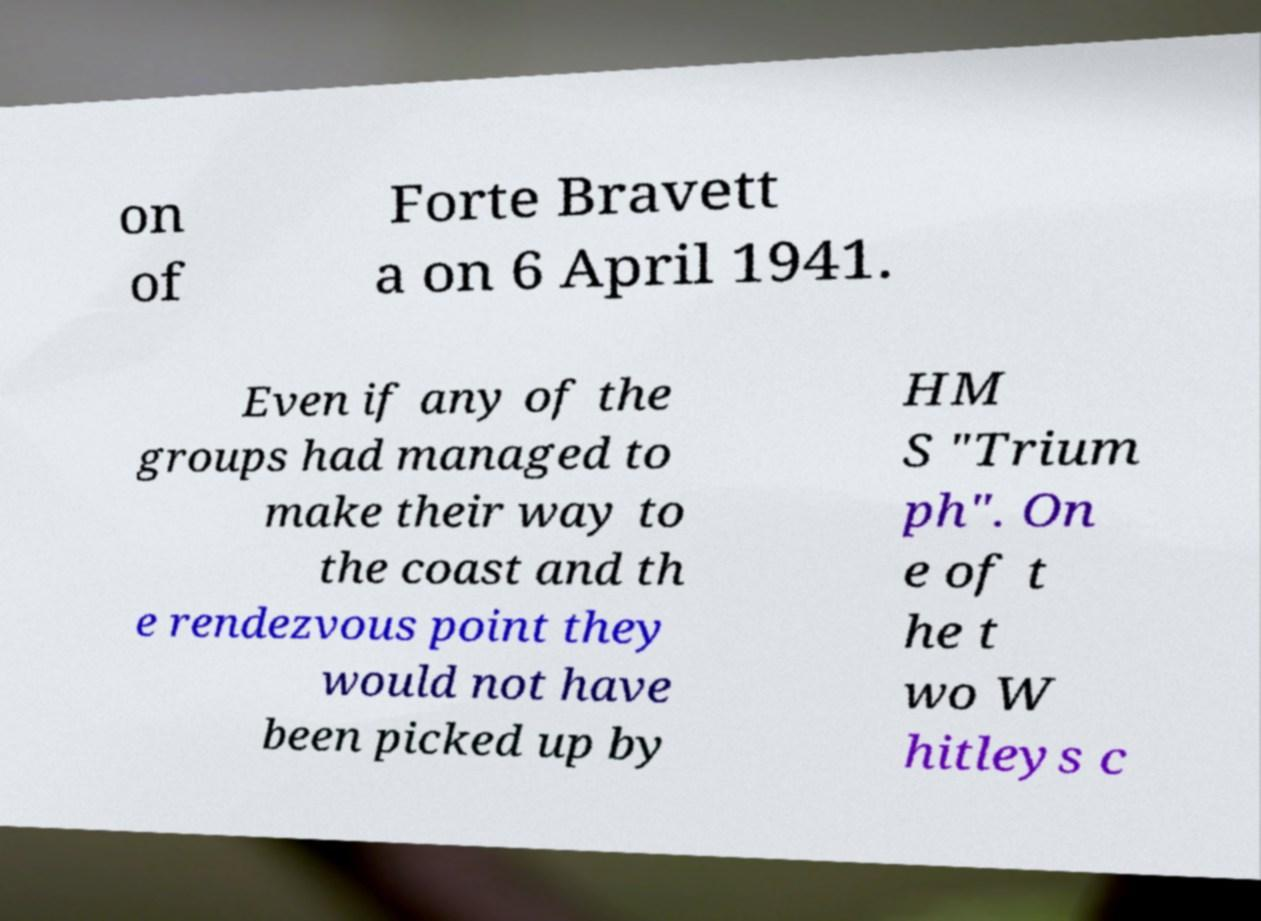Please read and relay the text visible in this image. What does it say? on of Forte Bravett a on 6 April 1941. Even if any of the groups had managed to make their way to the coast and th e rendezvous point they would not have been picked up by HM S "Trium ph". On e of t he t wo W hitleys c 